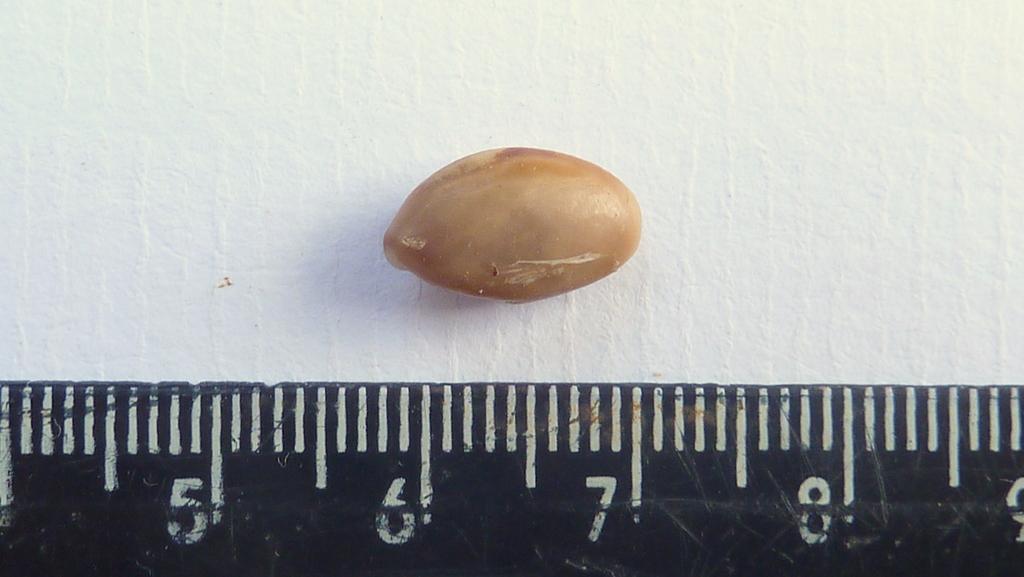How long is the bean?
Make the answer very short. 1 cm. What is the number on the far right of the ruler?
Offer a very short reply. 9. 